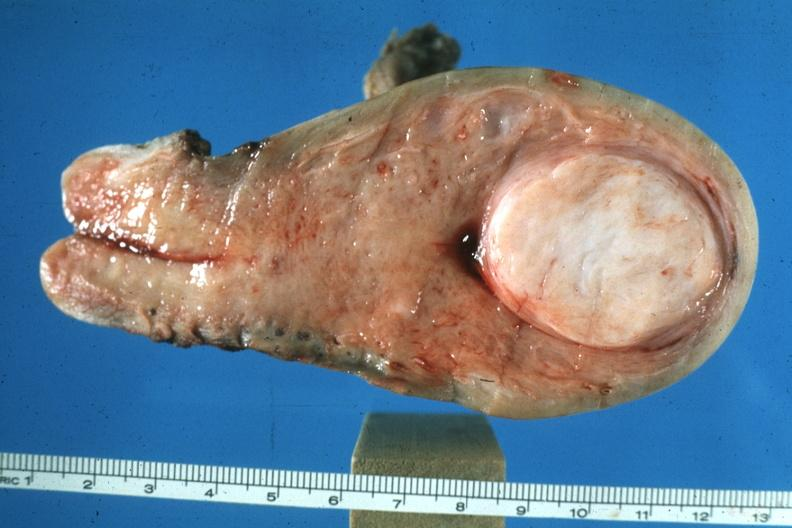what is present?
Answer the question using a single word or phrase. Female reproductive 